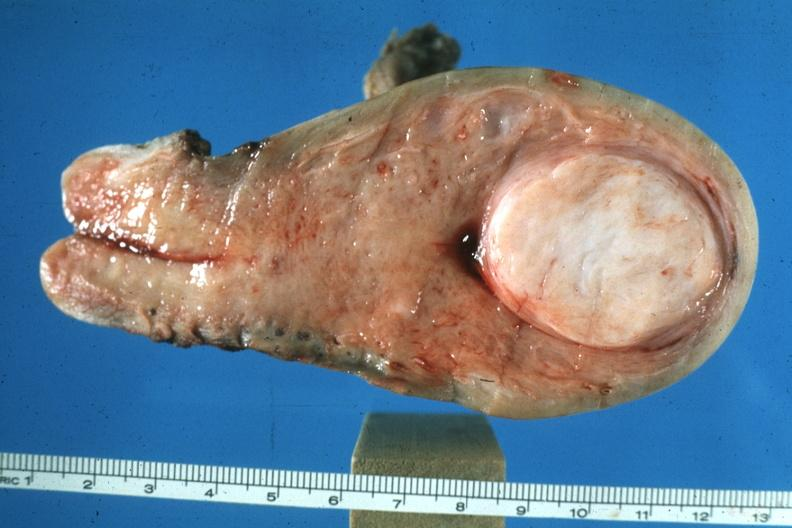what is present?
Answer the question using a single word or phrase. Female reproductive 